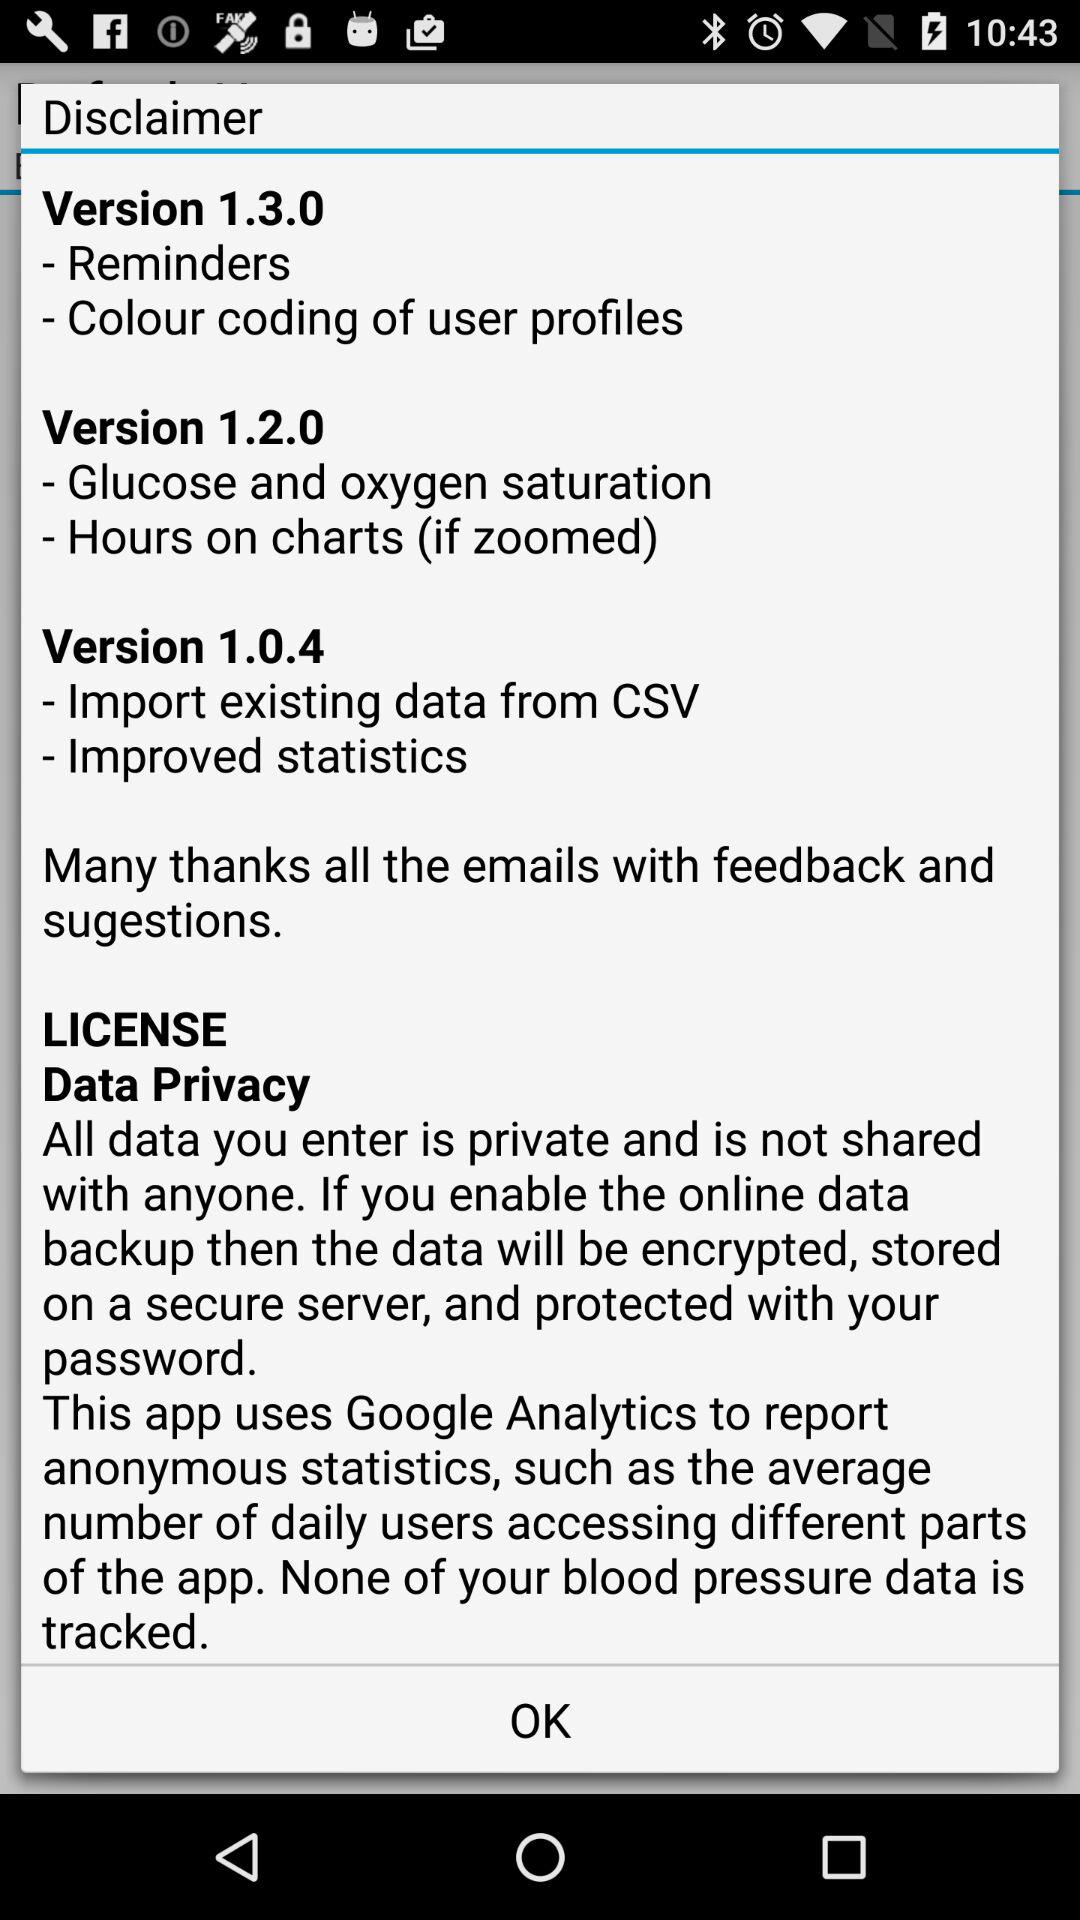Which version has the "Colour coding of user profiles" feature? The feature "Colour coding of user profiles" is in version 1.3.0. 